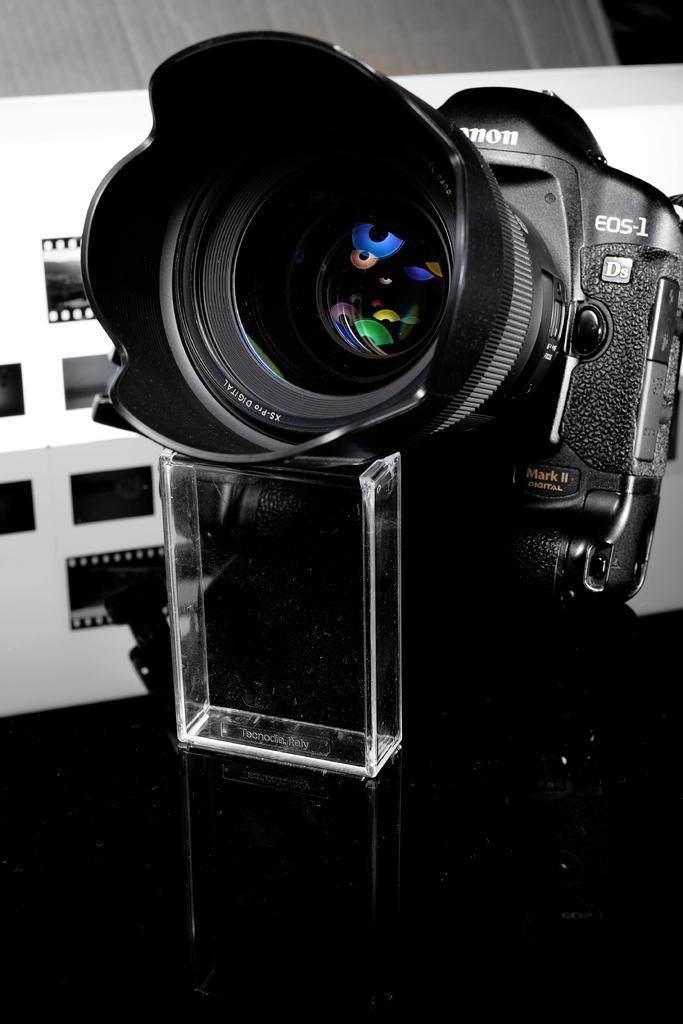Please provide a concise description of this image. In this image in the center there is one camera and in the background there is a wall, and on the wall there are some reels. 